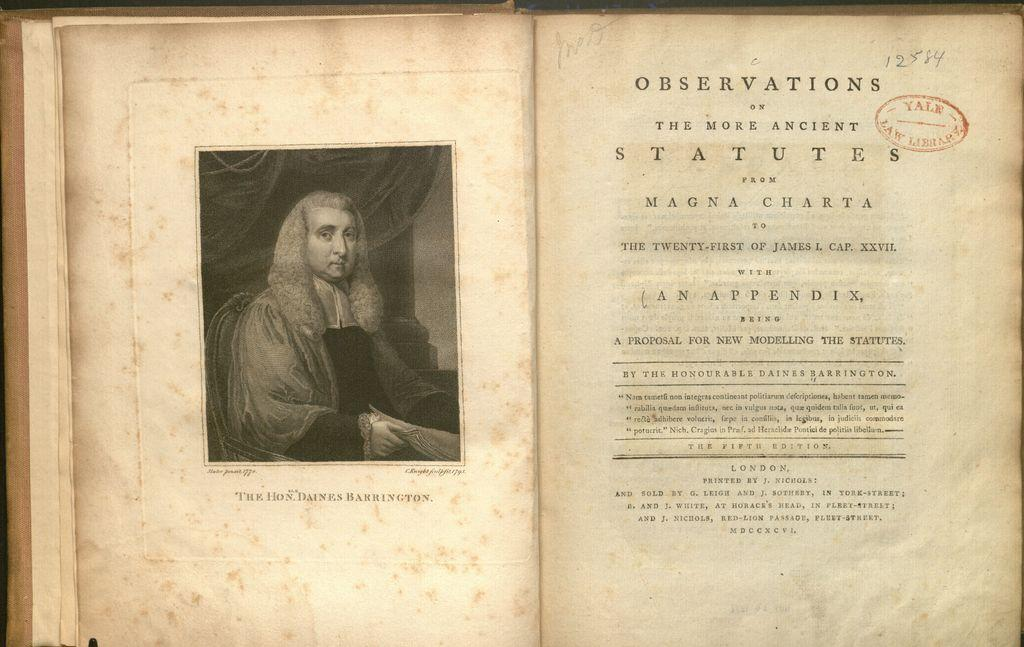<image>
Present a compact description of the photo's key features. An old open book with the title page saying Observations. 